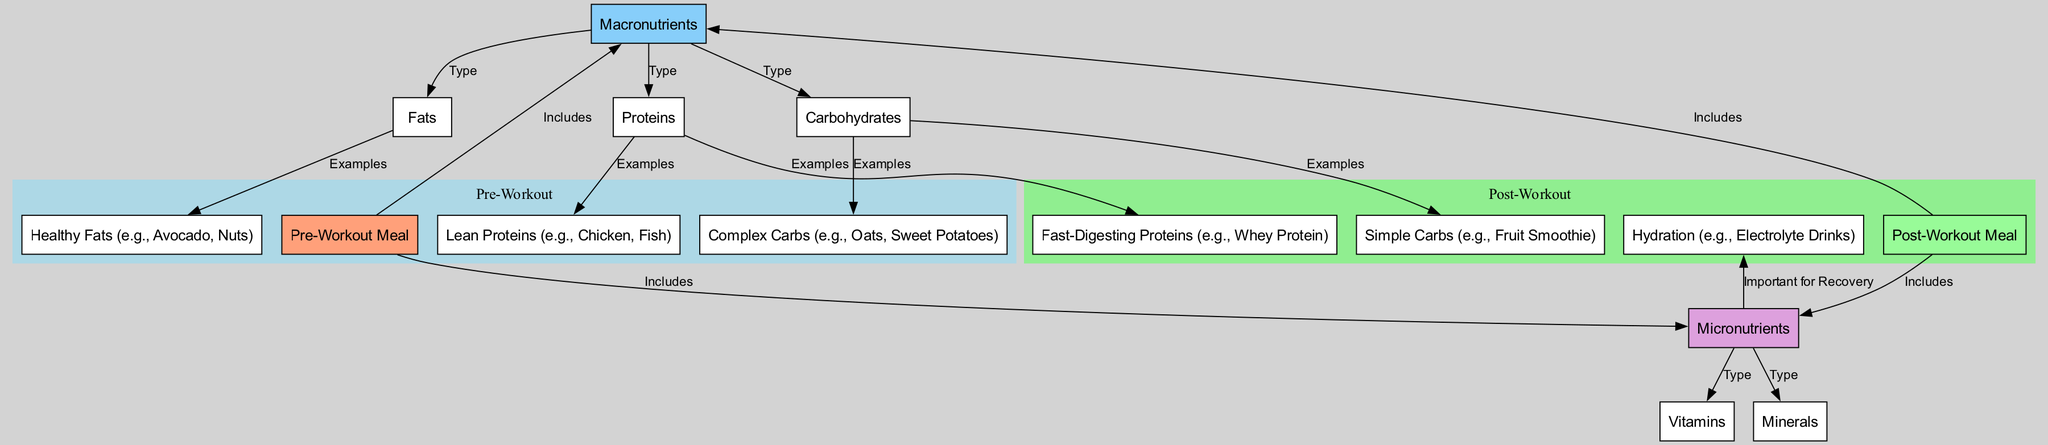What are the two main meal categories represented in the diagram? The diagram shows two primary meal categories: Pre-Workout Meal and Post-Workout Meal, each serving specific nutritional purposes.
Answer: Pre-Workout Meal, Post-Workout Meal How many macronutrients are indicated in the diagram? The diagram lists three types of macronutrients: Carbohydrates, Proteins, and Fats, which are clearly labeled under the Macronutrients section.
Answer: Three What type of carbohydrates are suggested for pre-workout meals? Under the Pre-Workout Meal, Complex Carbs are specifically mentioned as examples, including Oats and Sweet Potatoes.
Answer: Complex Carbs Which three examples of healthy fats are included in the post-workout meal category? The diagram indicates that Healthy Fats, such as Avocado and Nuts, are mentioned under Post-Workout Meal. Therefore, these two are included as examples, but the third example isn't specified in the context.
Answer: Avocado, Nuts What is identified as important for recovery in post-workout meals? Hydration is highlighted as an essential aspect for recovery after workouts, explicitly labeled in relation to micronutrients.
Answer: Hydration How are fast-digesting proteins classified in terms of their timing for consumption? Fast-Digesting Proteins, such as Whey Protein, are specifically categorized under Post-Workout Meal, indicating they are ideally consumed after a workout.
Answer: Post-Workout Meal What type of nutrients does the diagram include under the category of micronutrients? The diagram clearly segment micronutrients into Vitamins and Minerals, indicating their significance in overall nutrition.
Answer: Vitamins, Minerals Which examples are listed for simple carbohydrates in pre-workout meals? Simple Carbs are represented by the example of a Fruit Smoothie listed under the Pre-Workout Meal section of the diagram.
Answer: Fruit Smoothie What is the relationship between micronutrients and hydration in the diagram? The diagram shows that Hydration is linked as important for recovery and is categorized under Micronutrients, indicating its significance post-exercise.
Answer: Important for Recovery 